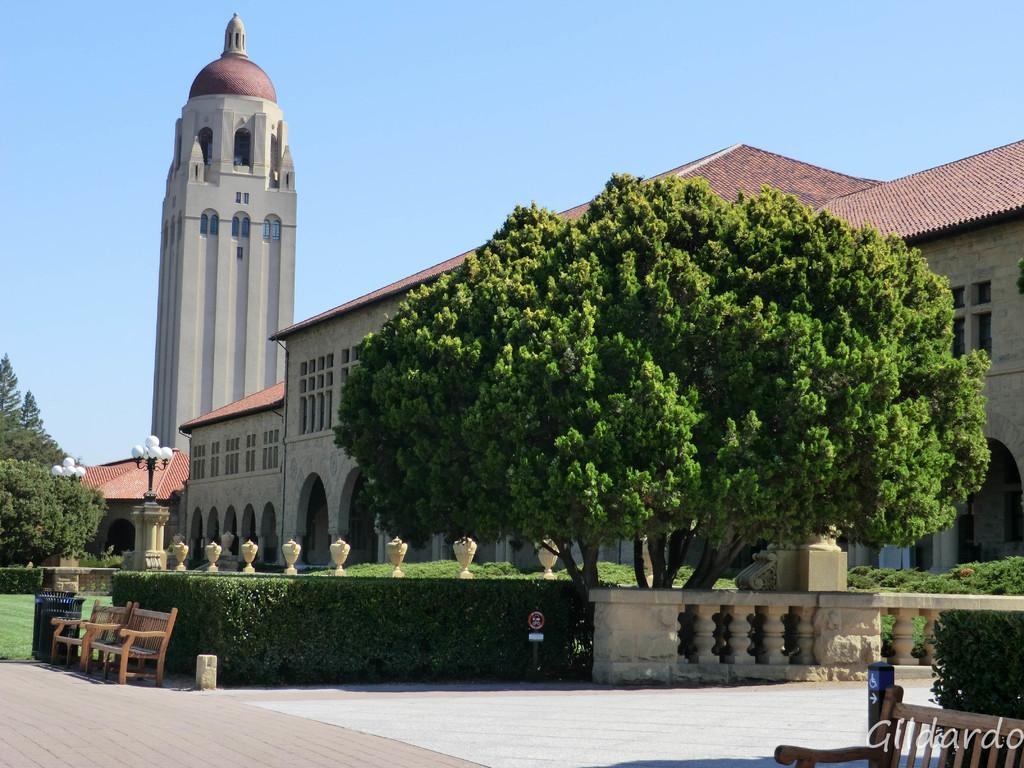What type of vegetation can be seen in the image? There are trees and plants in the image. What type of seating is available in the image? There are benches in the image. What type of ground surface is visible in the image? There is grass in the image. What type of lighting is present in the image? There are street lamps in the image. What type of structures are visible in the image? There are buildings in the image. What is visible at the top of the image? The sky is visible at the top of the image. What type of advice can be seen written on the trees in the image? There is no advice written on the trees in the image; it features trees, plants, benches, grass, street lamps, buildings, and the sky. What type of knife is being used to cut the grass in the image? There is no knife present in the image; it features trees, plants, benches, grass, street lamps, buildings, and the sky. 